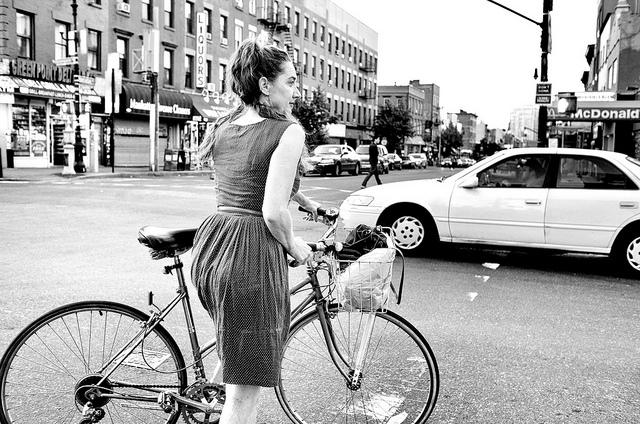Is the woman wearing pants?
Answer briefly. No. Is the woman in the picture having a bad day?
Answer briefly. No. Which cycle is woman riding?
Give a very brief answer. Bicycle. 